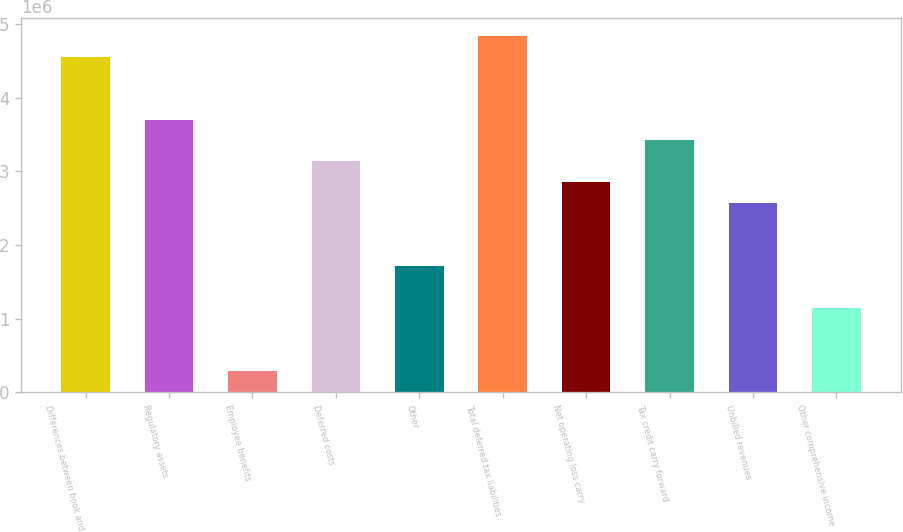Convert chart to OTSL. <chart><loc_0><loc_0><loc_500><loc_500><bar_chart><fcel>Differences between book and<fcel>Regulatory assets<fcel>Employee benefits<fcel>Deferred costs<fcel>Other<fcel>Total deferred tax liabilities<fcel>Net operating loss carry<fcel>Tax credit carry forward<fcel>Unbilled revenues<fcel>Other comprehensive income<nl><fcel>4.55767e+06<fcel>3.70472e+06<fcel>292893<fcel>3.13608e+06<fcel>1.71449e+06<fcel>4.84199e+06<fcel>2.85176e+06<fcel>3.4204e+06<fcel>2.56744e+06<fcel>1.14585e+06<nl></chart> 